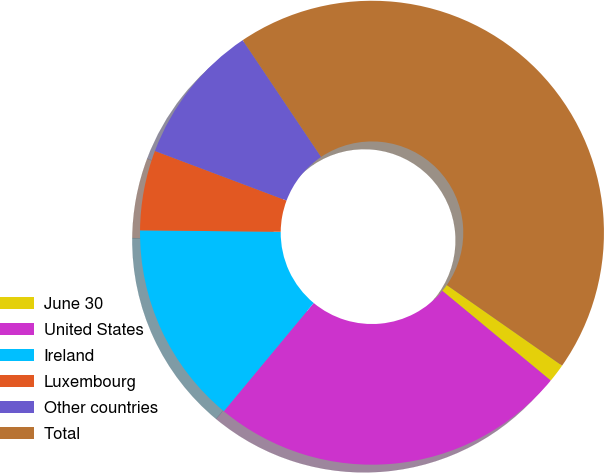<chart> <loc_0><loc_0><loc_500><loc_500><pie_chart><fcel>June 30<fcel>United States<fcel>Ireland<fcel>Luxembourg<fcel>Other countries<fcel>Total<nl><fcel>1.29%<fcel>25.03%<fcel>14.14%<fcel>5.57%<fcel>9.86%<fcel>44.12%<nl></chart> 